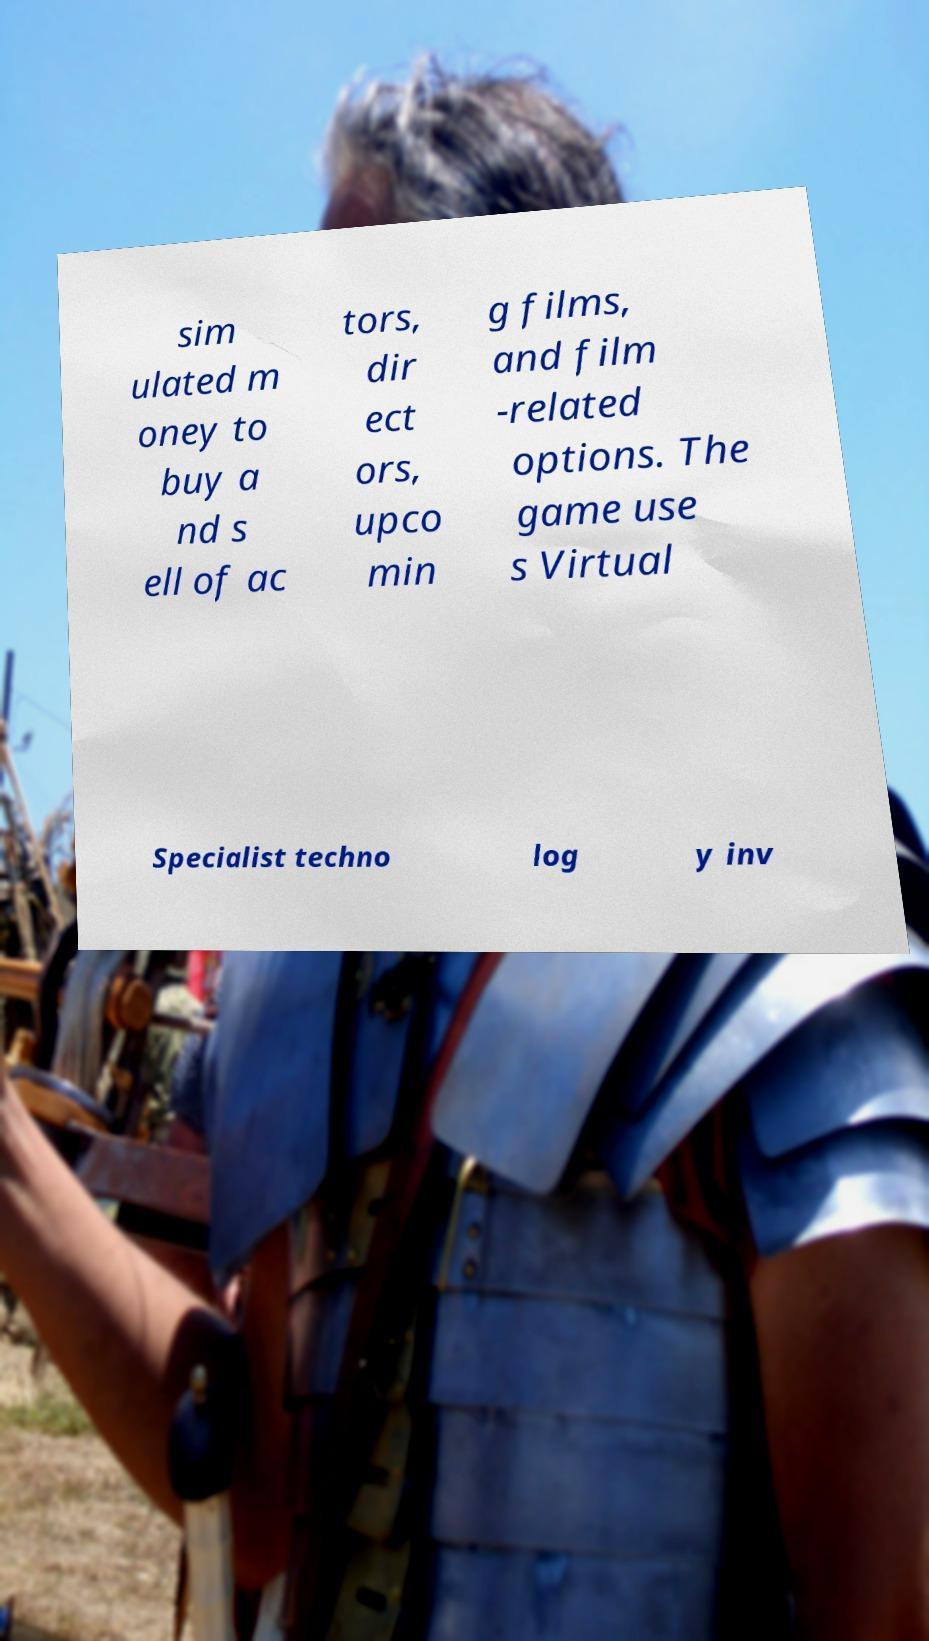For documentation purposes, I need the text within this image transcribed. Could you provide that? sim ulated m oney to buy a nd s ell of ac tors, dir ect ors, upco min g films, and film -related options. The game use s Virtual Specialist techno log y inv 